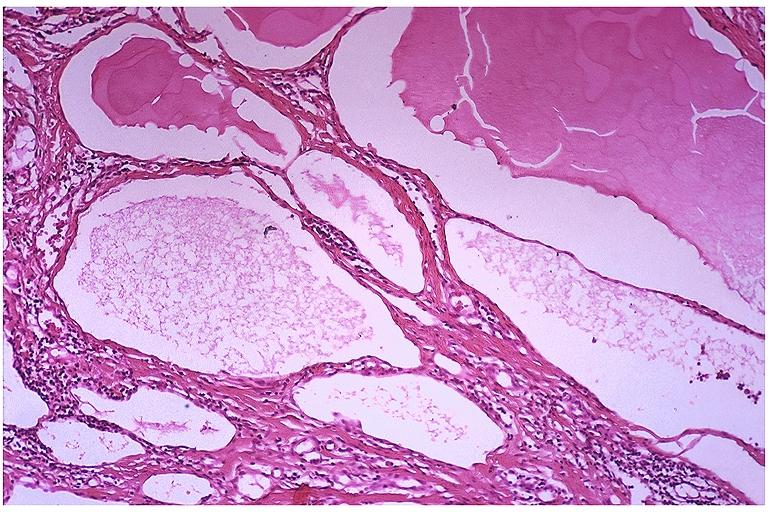does normal immature infant show lymphangioma?
Answer the question using a single word or phrase. No 